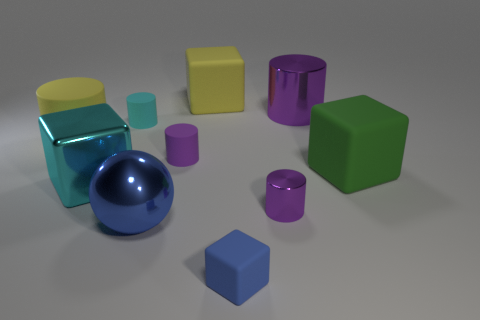There is a metal object that is right of the purple metallic thing that is in front of the big green cube; what is its color?
Ensure brevity in your answer.  Purple. There is a large shiny cube; is its color the same as the metal cylinder that is behind the yellow matte cylinder?
Give a very brief answer. No. What is the material of the cube that is both on the left side of the big green matte object and behind the cyan metallic cube?
Your answer should be compact. Rubber. Are there any brown shiny blocks that have the same size as the cyan cylinder?
Provide a succinct answer. No. What is the material of the cyan cylinder that is the same size as the blue matte object?
Ensure brevity in your answer.  Rubber. What number of big yellow blocks are to the left of the metallic ball?
Your answer should be very brief. 0. Is the shape of the large shiny thing to the left of the cyan matte cylinder the same as  the tiny shiny thing?
Provide a succinct answer. No. Is there a small cyan matte thing that has the same shape as the tiny blue thing?
Your answer should be very brief. No. There is a large sphere that is the same color as the small cube; what is it made of?
Your answer should be compact. Metal. The purple metallic object behind the big matte cube in front of the purple rubber thing is what shape?
Make the answer very short. Cylinder. 